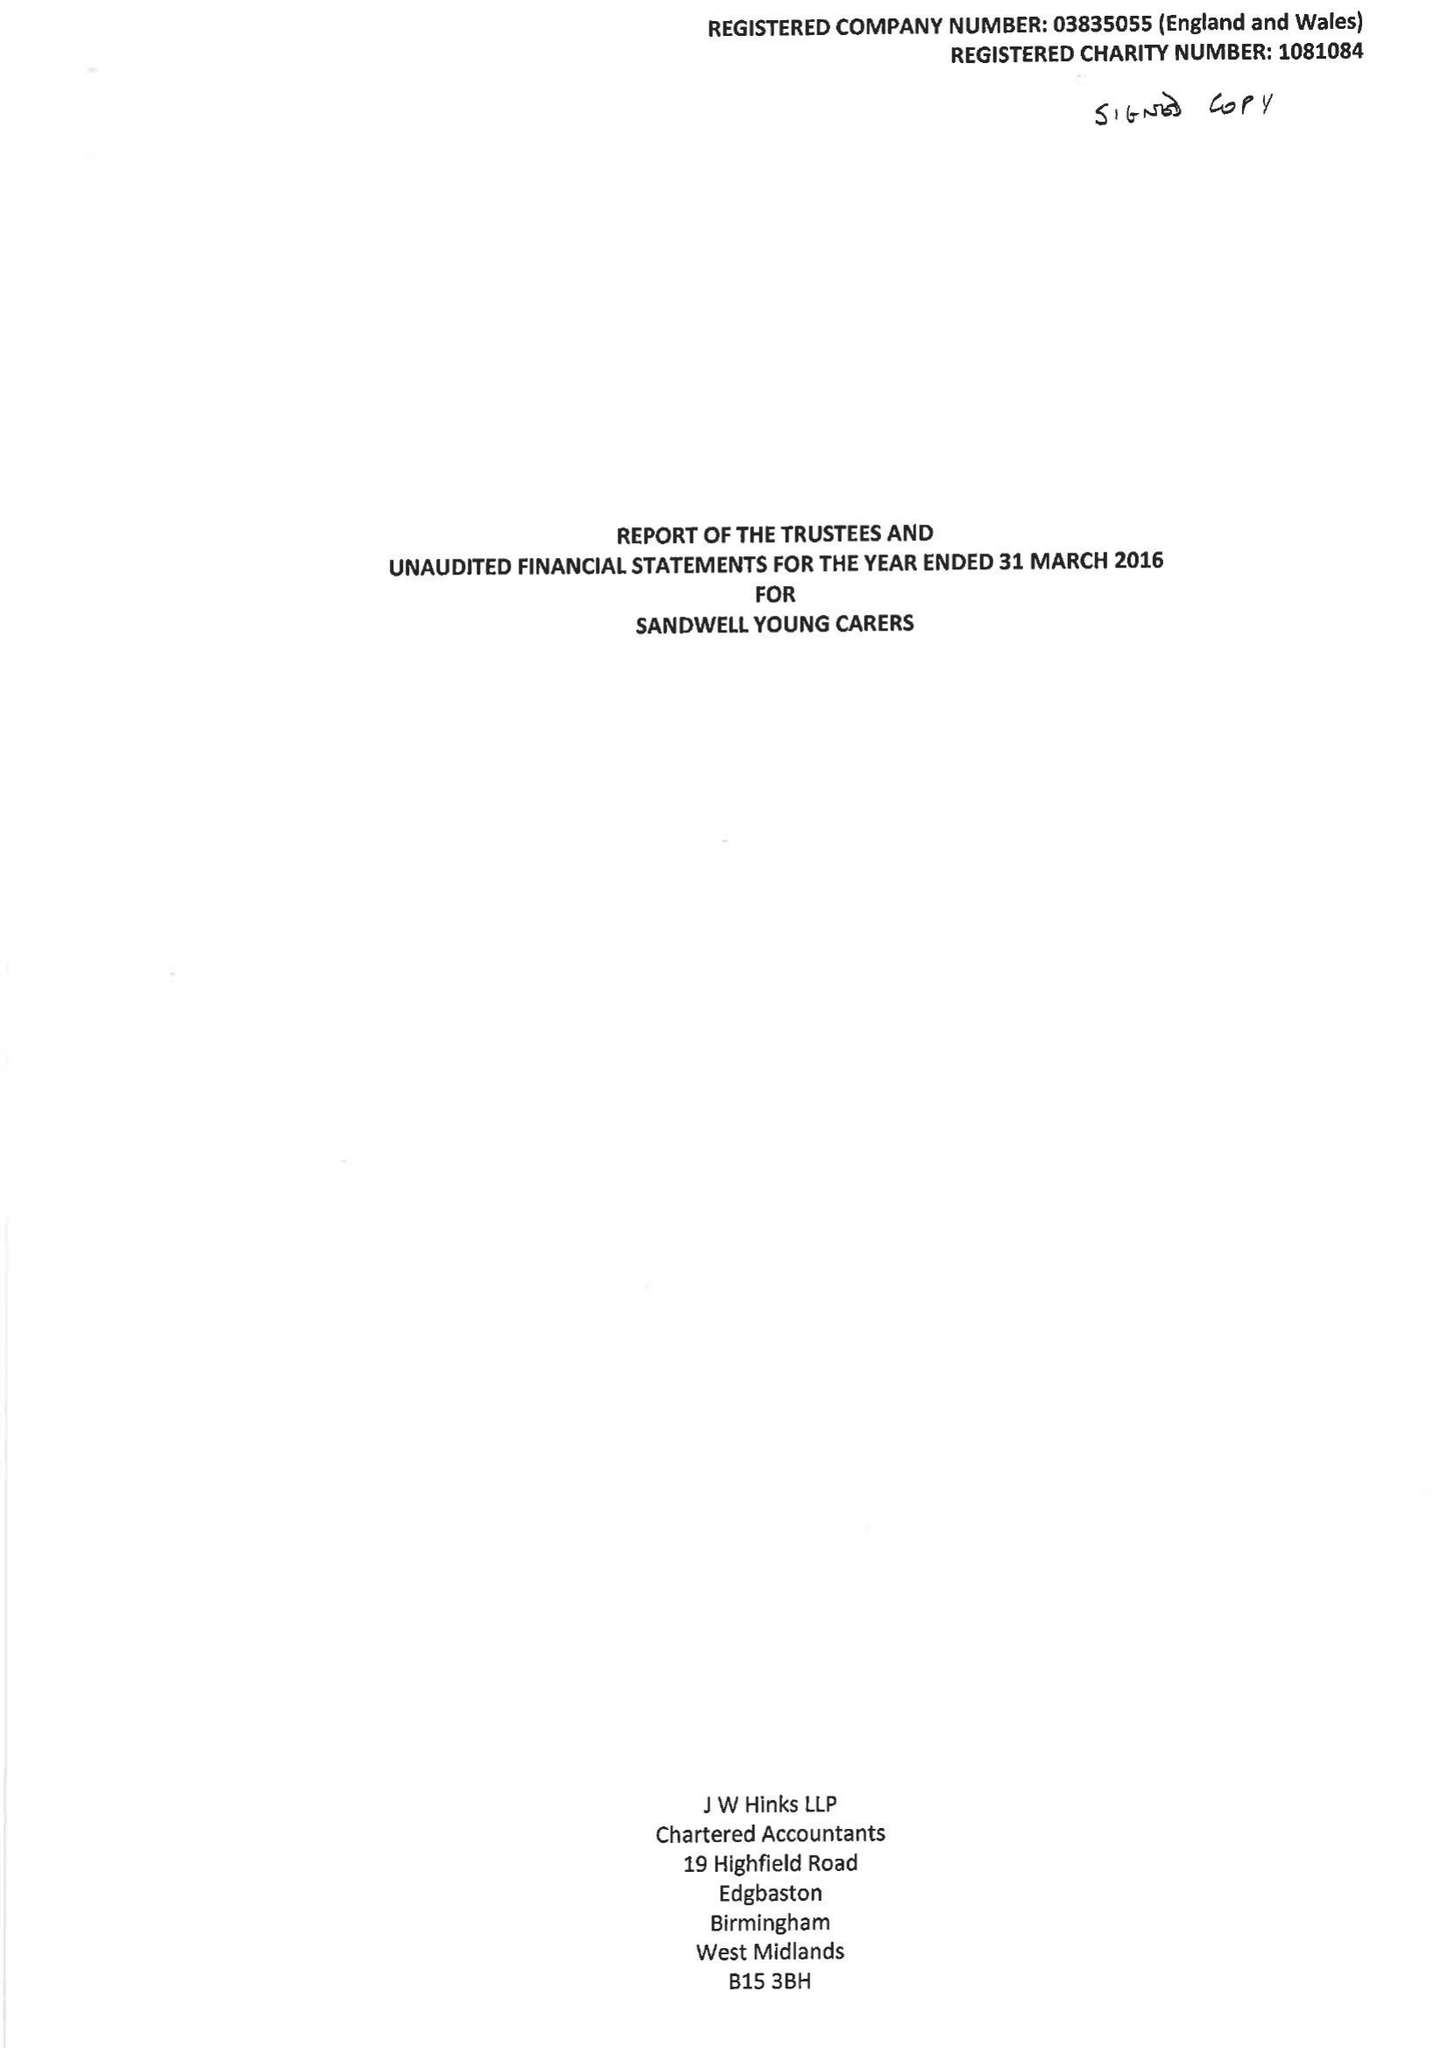What is the value for the address__post_town?
Answer the question using a single word or phrase. WEST BROMWICH 